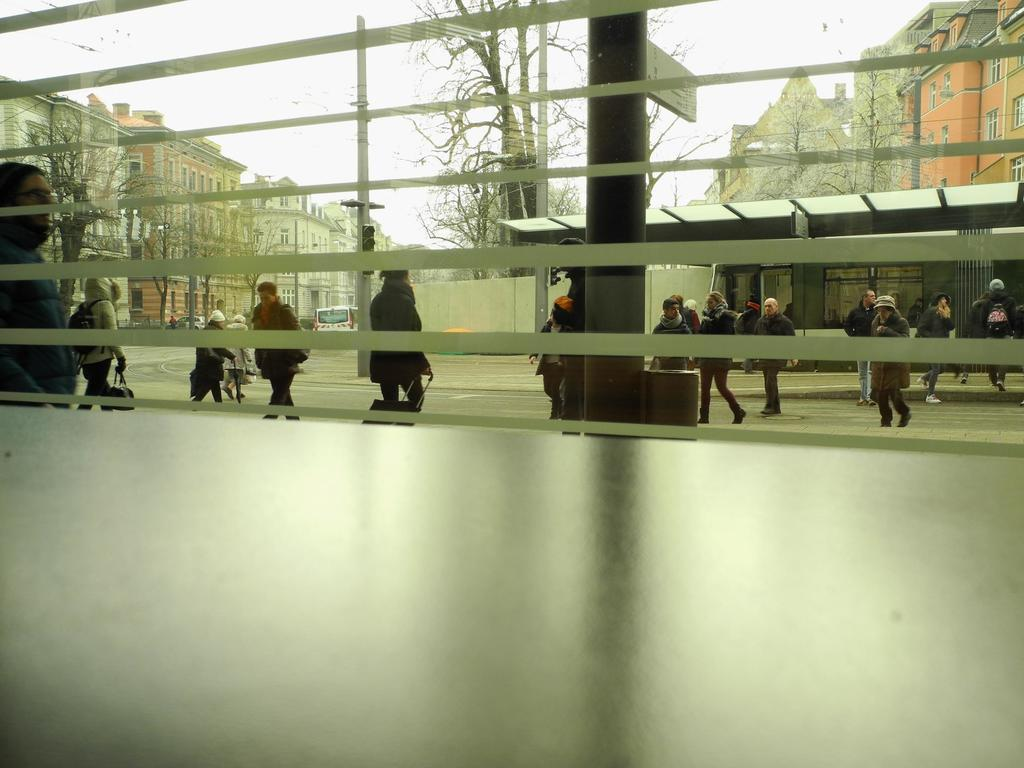What object is present in the image that has a transparent surface? There is a glass in the image. What can be seen through the glass in the image? People, buildings, trees, moles, a sign board, traffic lights, a shed, and vehicles can be seen through the glass. What is visible in the background of the image? The sky is visible in the background of the image. What type of music can be heard playing in the background of the image? There is no music present in the image, as it only shows a glass with various objects visible through it. 